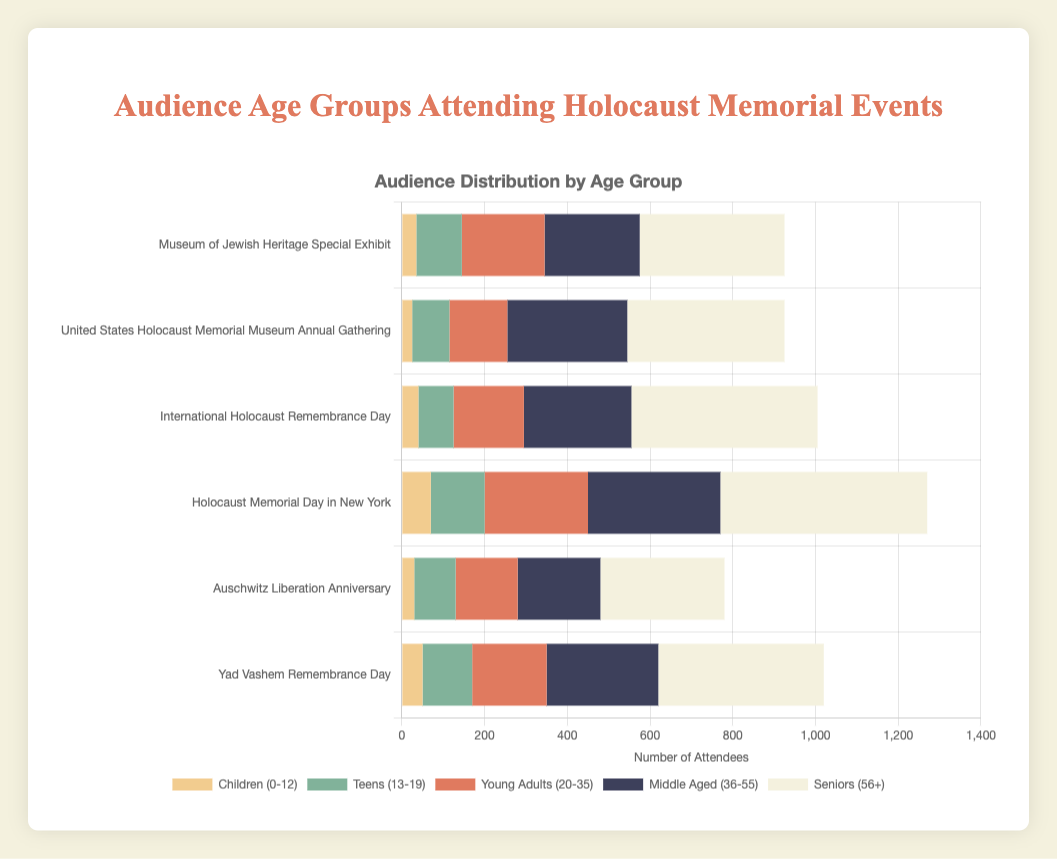Which event had the highest number of Teens (13-19) attendees? By looking at the height of the respective colored segment for the Teens (13-19) age group, we can see the "Holocaust Memorial Day in New York" has the tallest green section, indicating the highest number of teen attendees, which is 130.
Answer: Holocaust Memorial Day in New York Which event had the least number of Children (0-12) attendees? By observing the shortest segment of the color associated with the Children (0-12) age group, it is evident that the "United States Holocaust Memorial Museum Annual Gathering" has the shortest section, indicating the least number of child attendees, which is 25.
Answer: United States Holocaust Memorial Museum Annual Gathering How many more Seniors (56+) attended "Yad Vashem Remembrance Day" compared to "Auschwitz Liberation Anniversary"? The number of Seniors (56+) at "Yad Vashem Remembrance Day" is 400 and at "Auschwitz Liberation Anniversary" is 300. The difference is 400 - 300 = 100.
Answer: 100 Which age group is most prevalent in the "Museum of Jewish Heritage Special Exhibit"? By examining the lengths of the different colored segments for the "Museum of Jewish Heritage Special Exhibit", the longest section is the beige color representing the Seniors (56+), which has a length indicating 350 attendees.
Answer: Seniors (56+) What is the total number of Young Adults (20-35) attendees across all events? Add the values of the Young Adults (20-35) category from all events: 200 + 140 + 170 + 250 + 150 + 180. This results in a total of 1090 attendees.
Answer: 1090 Compare the number of Middle Aged (36-55) attendees at "Holocaust Memorial Day in New York" and "Auschwitz Liberation Anniversary". Which is higher? The "Holocaust Memorial Day in New York" has 320 middle aged attendees, whereas the "Auschwitz Liberation Anniversary" has 200. Therefore, "Holocaust Memorial Day in New York" has a higher number of attendees in this age group.
Answer: Holocaust Memorial Day in New York Which two events have the closest number of overall attendees? Calculate the total for each event: 
"Yad Vashem Remembrance Day": 50+120+180+270+400 = 1020 
"Auschwitz Liberation Anniversary": 30+100+150+200+300 = 780
"Holocaust Memorial Day in New York": 70+130+250+320+500 = 1270
"International Holocaust Remembrance Day": 40+85+170+260+450 = 1005
"United States Holocaust Memorial Museum Annual Gathering": 25+90+140+290+380 = 925
"Museum of Jewish Heritage Special Exhibit": 35+110+200+230+350 = 925
The closest total attendees are at "United States Holocaust Memorial Museum Annual Gathering" and "Museum of Jewish Heritage Special Exhibit".
Answer: United States Holocaust Memorial Museum Annual Gathering and Museum of Jewish Heritage Special Exhibit 